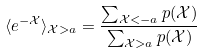<formula> <loc_0><loc_0><loc_500><loc_500>\langle e ^ { - \mathcal { X } } \rangle _ { \mathcal { X } > a } = \frac { \sum _ { \mathcal { X } < - a } p ( \mathcal { X } ) } { \sum _ { \mathcal { X } > a } p ( \mathcal { X } ) }</formula> 